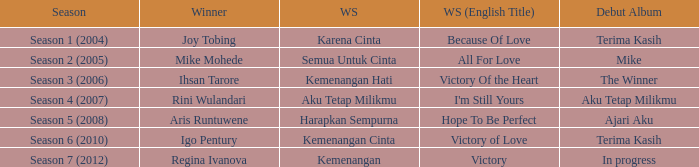Which album debuted in season 2 (2005)? Mike. 